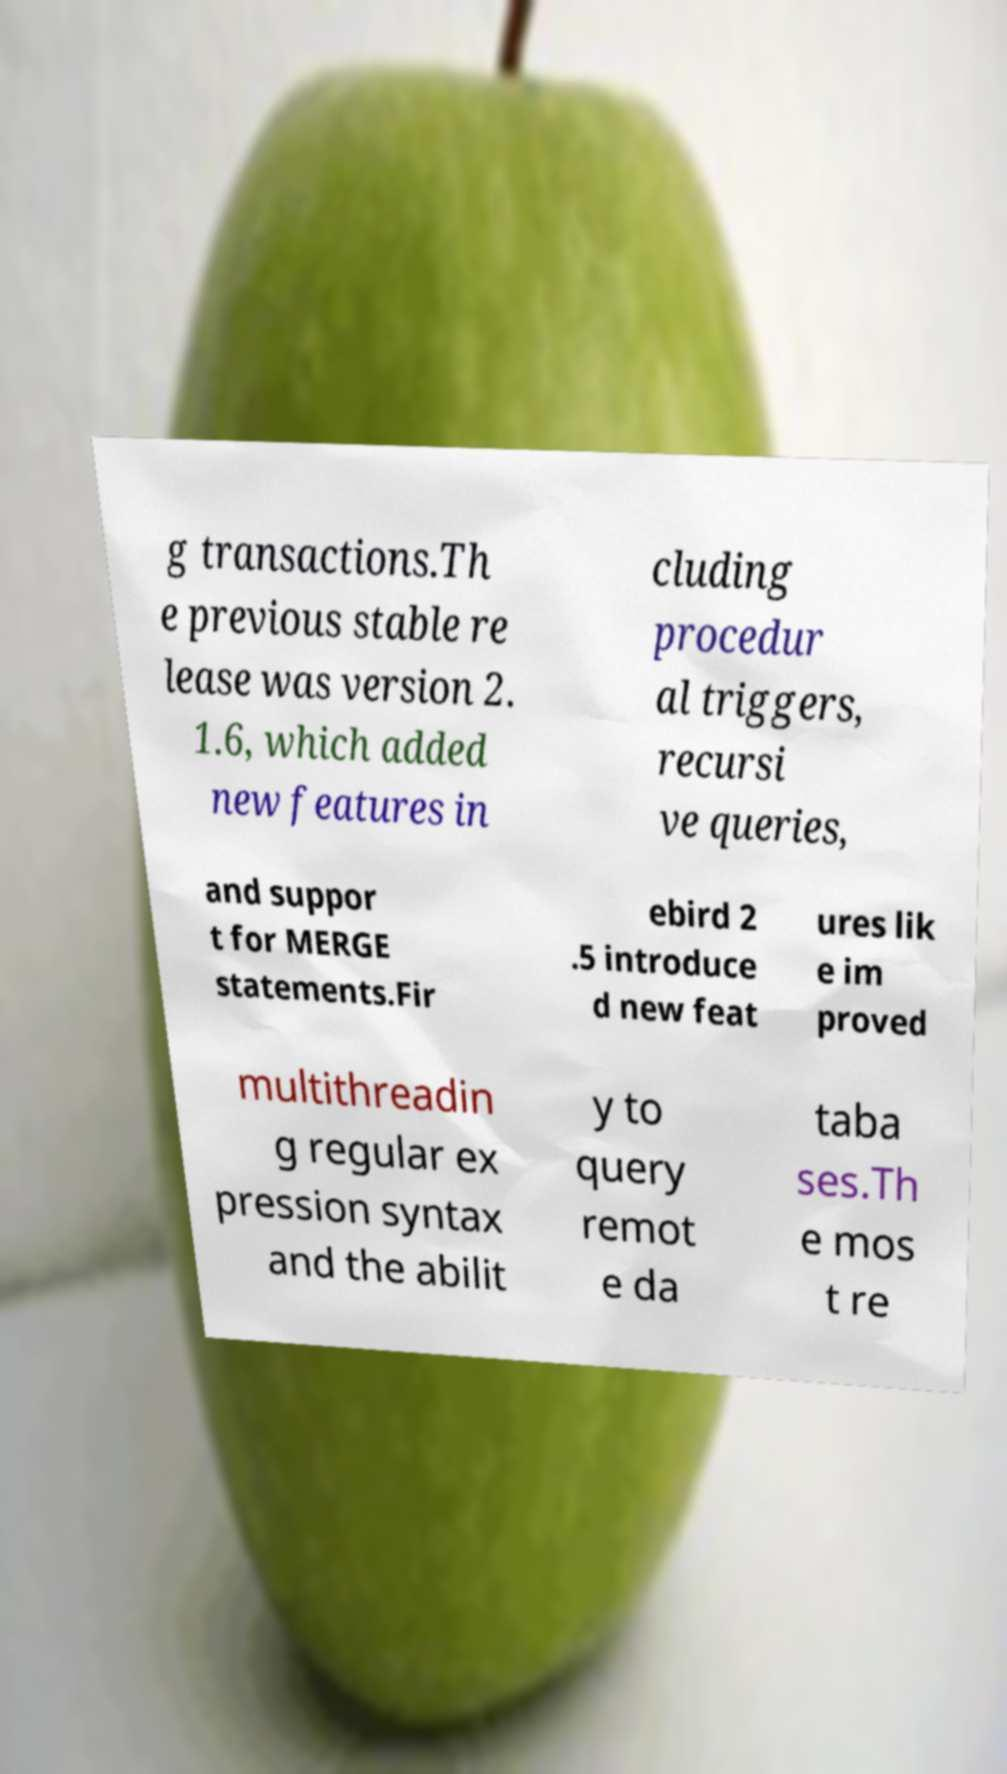Could you extract and type out the text from this image? g transactions.Th e previous stable re lease was version 2. 1.6, which added new features in cluding procedur al triggers, recursi ve queries, and suppor t for MERGE statements.Fir ebird 2 .5 introduce d new feat ures lik e im proved multithreadin g regular ex pression syntax and the abilit y to query remot e da taba ses.Th e mos t re 